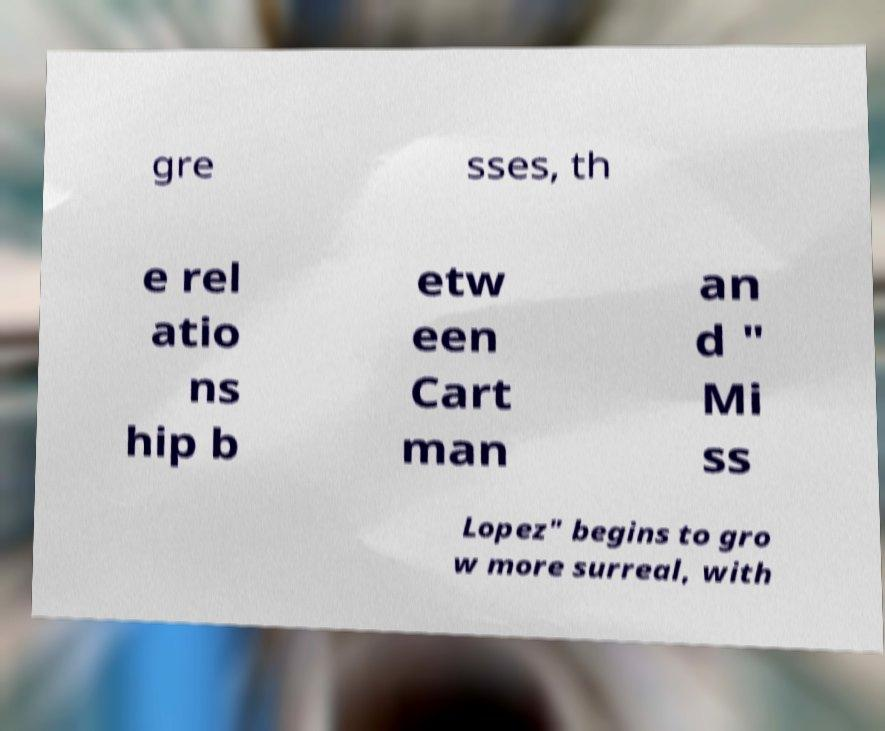What messages or text are displayed in this image? I need them in a readable, typed format. gre sses, th e rel atio ns hip b etw een Cart man an d " Mi ss Lopez" begins to gro w more surreal, with 